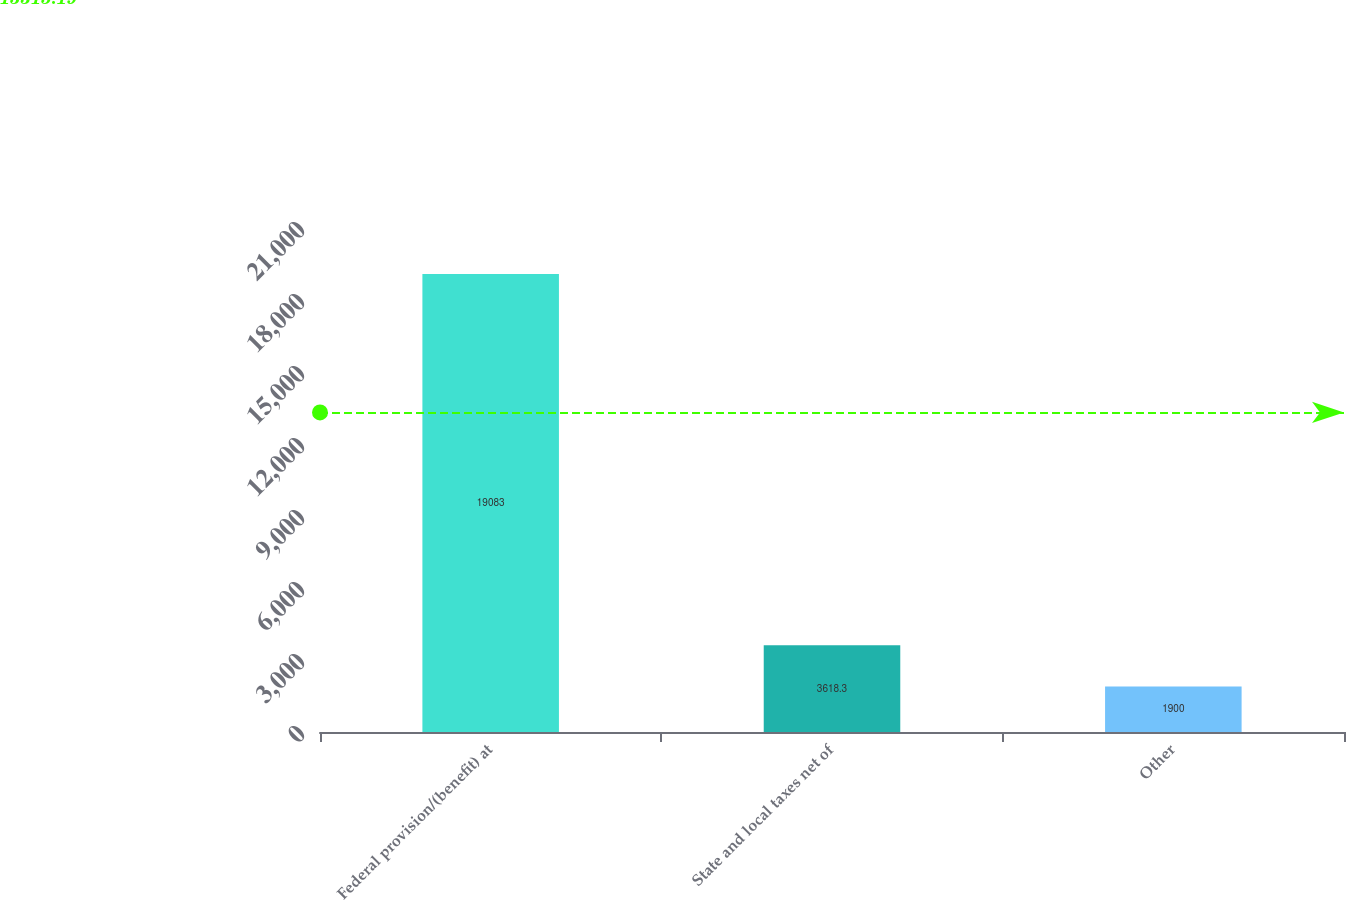<chart> <loc_0><loc_0><loc_500><loc_500><bar_chart><fcel>Federal provision/(benefit) at<fcel>State and local taxes net of<fcel>Other<nl><fcel>19083<fcel>3618.3<fcel>1900<nl></chart> 